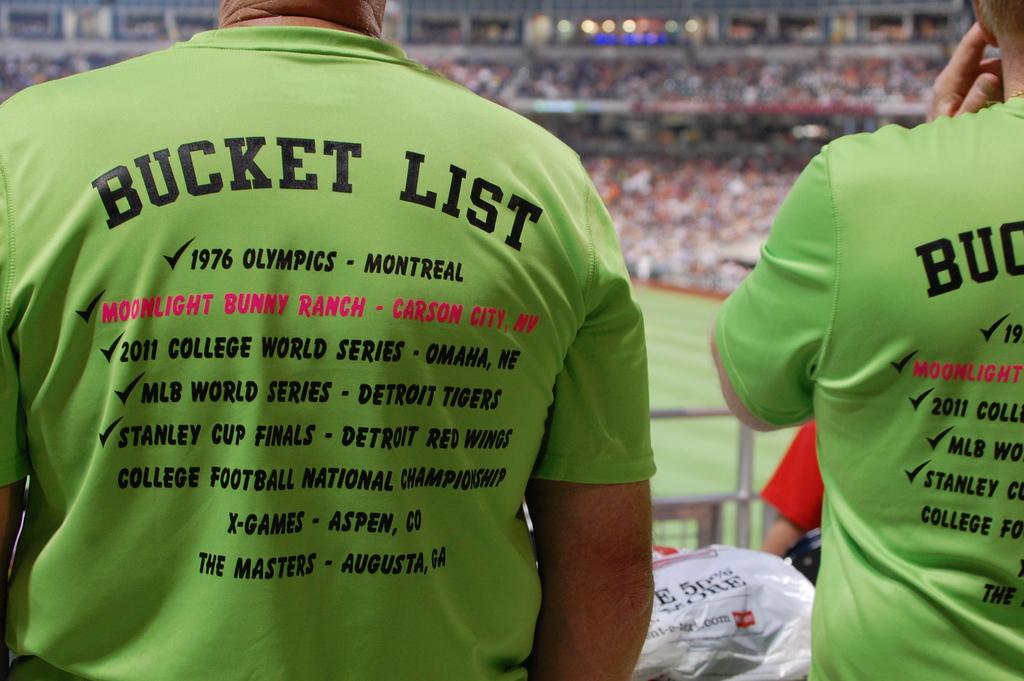Who was playing the stanley cup finals?
Provide a short and direct response. Detroit red wings. 